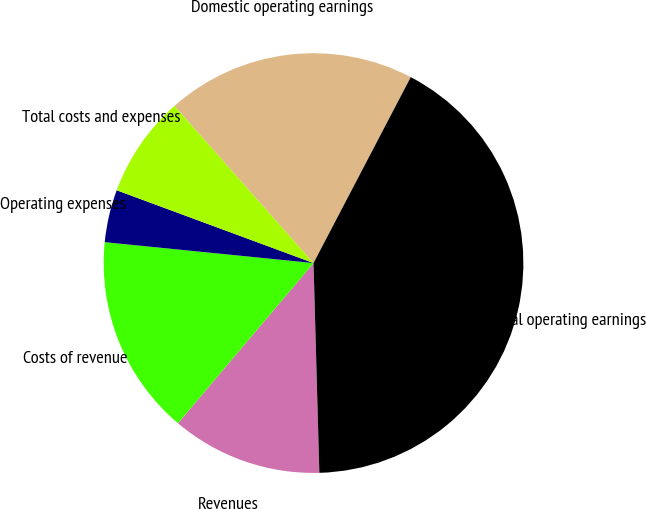Convert chart. <chart><loc_0><loc_0><loc_500><loc_500><pie_chart><fcel>Revenues<fcel>Costs of revenue<fcel>Operating expenses<fcel>Total costs and expenses<fcel>Domestic operating earnings<fcel>Global operating earnings<nl><fcel>11.62%<fcel>15.41%<fcel>4.05%<fcel>7.84%<fcel>19.19%<fcel>41.89%<nl></chart> 